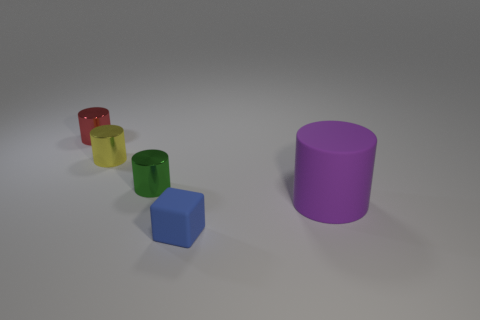Subtract all small cylinders. How many cylinders are left? 1 Subtract all yellow cylinders. How many cylinders are left? 3 Add 4 yellow shiny cylinders. How many objects exist? 9 Subtract all cubes. How many objects are left? 4 Subtract all cyan cylinders. Subtract all yellow balls. How many cylinders are left? 4 Subtract all small green shiny cylinders. Subtract all green cylinders. How many objects are left? 3 Add 2 small red cylinders. How many small red cylinders are left? 3 Add 2 tiny matte objects. How many tiny matte objects exist? 3 Subtract 0 cyan spheres. How many objects are left? 5 